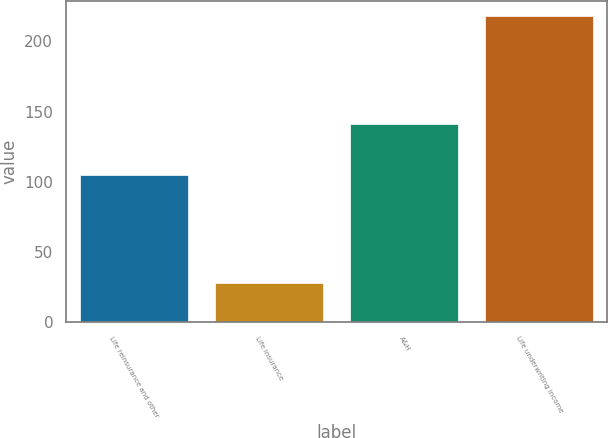<chart> <loc_0><loc_0><loc_500><loc_500><bar_chart><fcel>Life reinsurance and other<fcel>Life insurance<fcel>A&H<fcel>Life underwriting income<nl><fcel>105<fcel>28<fcel>141<fcel>218<nl></chart> 